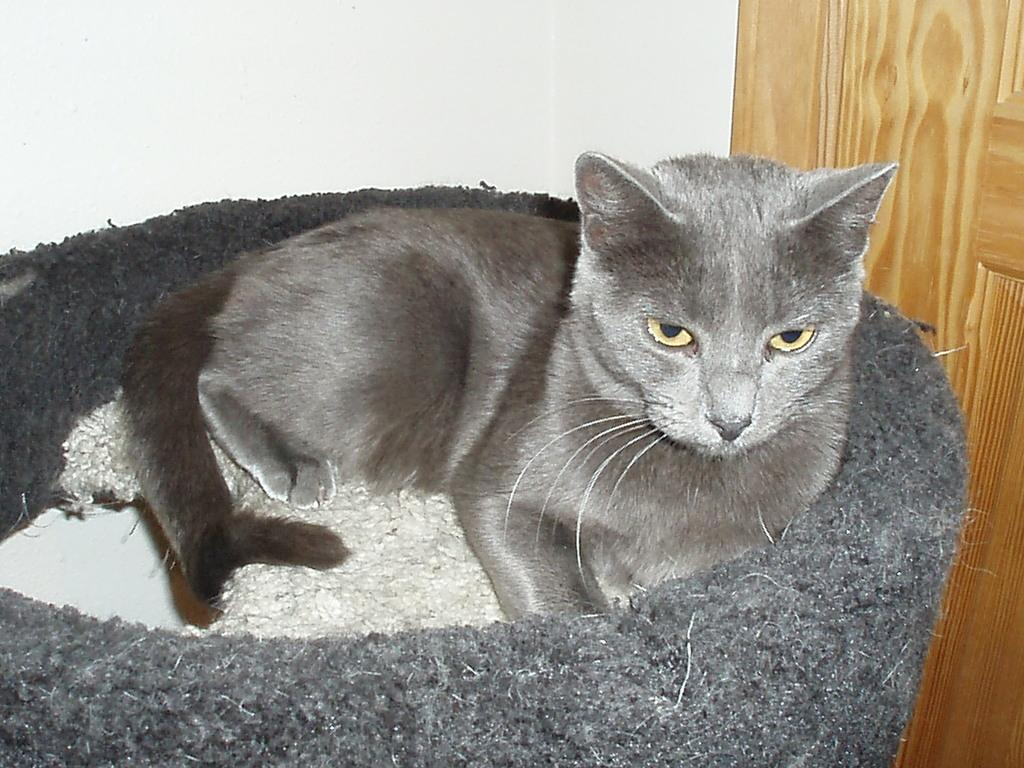What type of animal is in the image? There is a cat in the image. What colors can be seen on the cat? The cat is in ash and grey color. What is the cat sitting or standing on? The cat is on a white and grey color object. What can be seen in the background of the image? There is a white and brown color wall in the background of the image. What type of mine is depicted in the image? There is no mine present in the image; it features a cat on an object. What disease is the cat suffering from in the image? There is no indication of any disease in the image of the cat. 